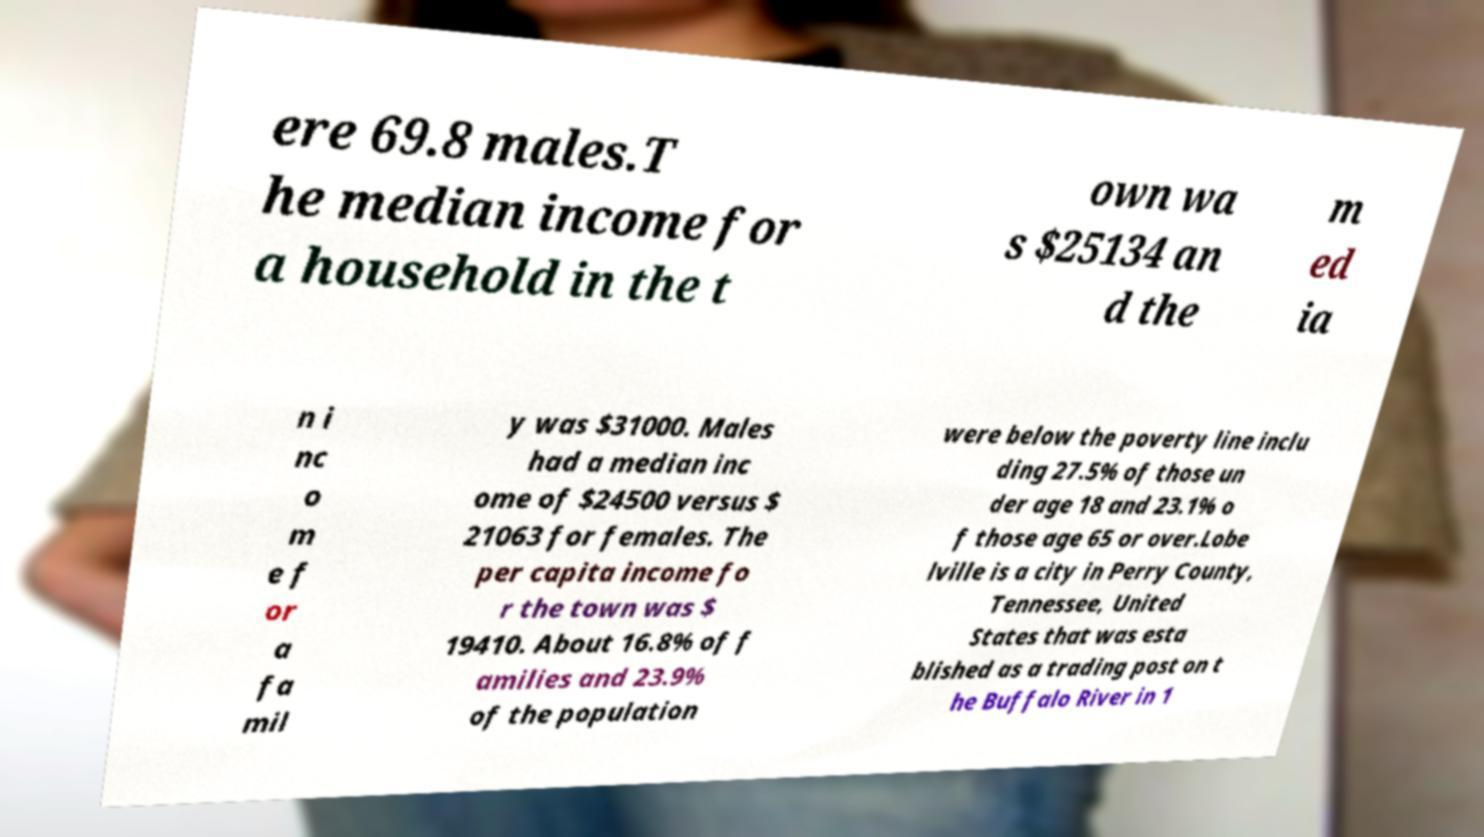Please identify and transcribe the text found in this image. ere 69.8 males.T he median income for a household in the t own wa s $25134 an d the m ed ia n i nc o m e f or a fa mil y was $31000. Males had a median inc ome of $24500 versus $ 21063 for females. The per capita income fo r the town was $ 19410. About 16.8% of f amilies and 23.9% of the population were below the poverty line inclu ding 27.5% of those un der age 18 and 23.1% o f those age 65 or over.Lobe lville is a city in Perry County, Tennessee, United States that was esta blished as a trading post on t he Buffalo River in 1 